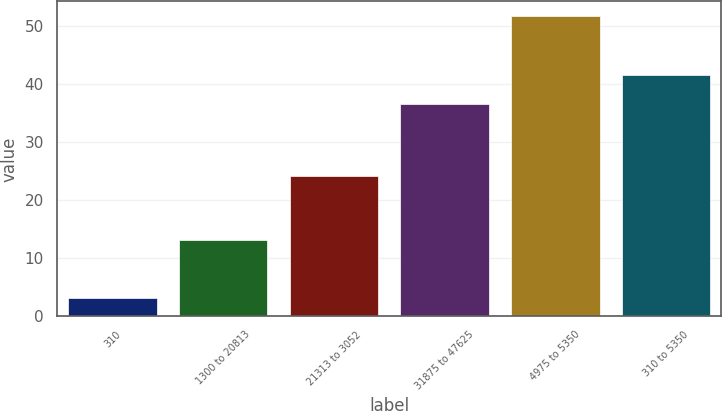Convert chart to OTSL. <chart><loc_0><loc_0><loc_500><loc_500><bar_chart><fcel>310<fcel>1300 to 20813<fcel>21313 to 3052<fcel>31875 to 47625<fcel>4975 to 5350<fcel>310 to 5350<nl><fcel>3.1<fcel>13.13<fcel>24.22<fcel>36.67<fcel>51.71<fcel>41.53<nl></chart> 